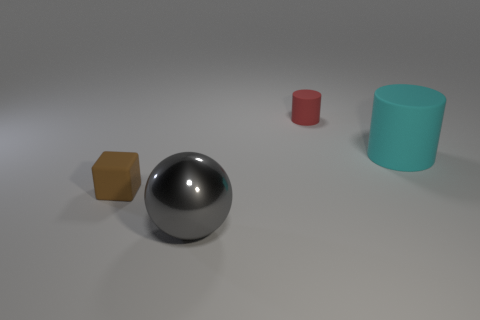Is there any other thing that is the same material as the cyan cylinder?
Keep it short and to the point. Yes. Do the small thing in front of the tiny red matte cylinder and the rubber thing that is to the right of the red rubber object have the same color?
Your response must be concise. No. How many things are both in front of the red rubber object and behind the brown rubber object?
Offer a very short reply. 1. How many other things are there of the same shape as the gray object?
Offer a very short reply. 0. Is the number of cylinders in front of the large cyan thing greater than the number of small blue things?
Your response must be concise. No. There is a object behind the cyan object; what is its color?
Keep it short and to the point. Red. What number of metallic things are tiny cyan cylinders or brown things?
Your answer should be compact. 0. There is a matte cylinder that is to the left of the big thing that is on the right side of the large metal object; are there any rubber cubes behind it?
Offer a terse response. No. What number of blocks are behind the gray thing?
Your response must be concise. 1. How many tiny objects are either blue rubber balls or cyan matte cylinders?
Your response must be concise. 0. 